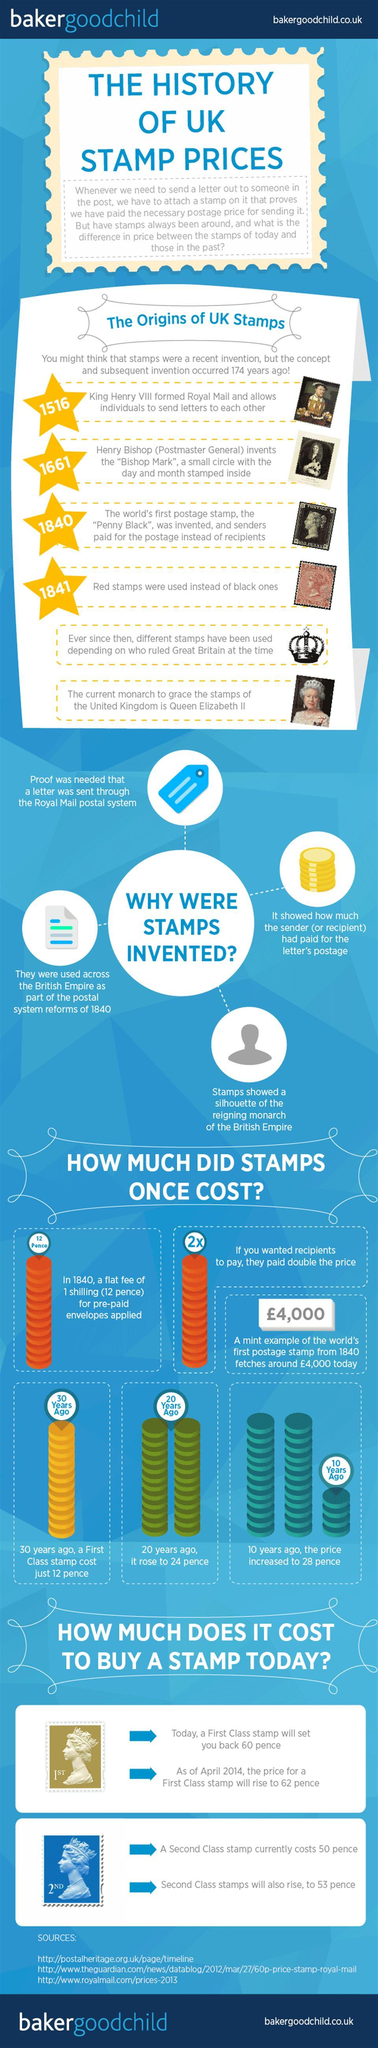Identify some key points in this picture. At present, Queen Elizabeth II is featured on the stamps of the United Kingdom. There are three sources listed at the bottom. In the year 1840, the Penny Black was introduced. 